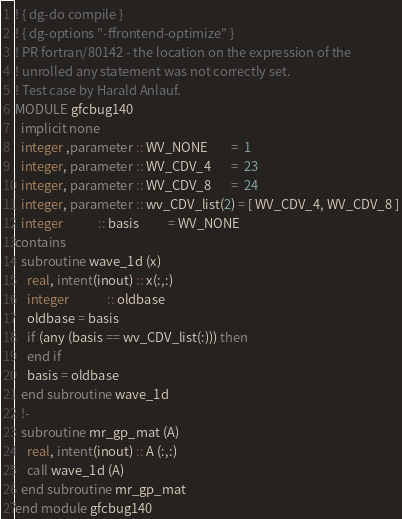Convert code to text. <code><loc_0><loc_0><loc_500><loc_500><_FORTRAN_>! { dg-do compile }
! { dg-options "-ffrontend-optimize" }
! PR fortran/80142 - the location on the expression of the
! unrolled any statement was not correctly set.
! Test case by Harald Anlauf.
MODULE gfcbug140
  implicit none
  integer ,parameter :: WV_NONE        =  1
  integer, parameter :: WV_CDV_4       =  23
  integer, parameter :: WV_CDV_8       =  24
  integer, parameter :: wv_CDV_list(2) = [ WV_CDV_4, WV_CDV_8 ]
  integer            :: basis          = WV_NONE
contains
  subroutine wave_1d (x)
    real, intent(inout) :: x(:,:)
    integer             :: oldbase
    oldbase = basis
    if (any (basis == wv_CDV_list(:))) then
    end if
    basis = oldbase
  end subroutine wave_1d
  !-
  subroutine mr_gp_mat (A)
    real, intent(inout) :: A (:,:)
    call wave_1d (A)
  end subroutine mr_gp_mat
end module gfcbug140
</code> 